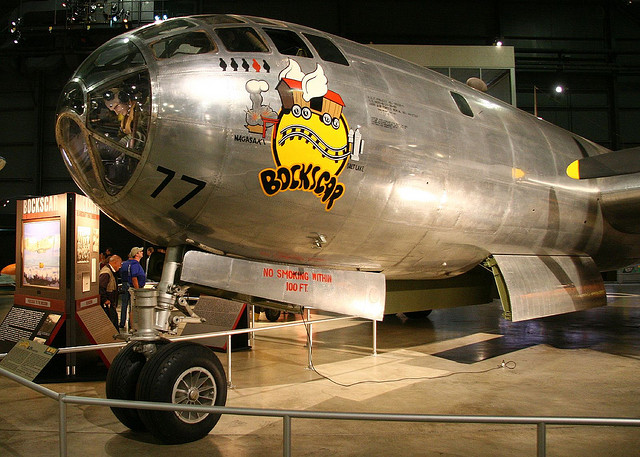Read all the text in this image. 100 FT NO SMOKING WITHIN 77 BOCKSCAR 